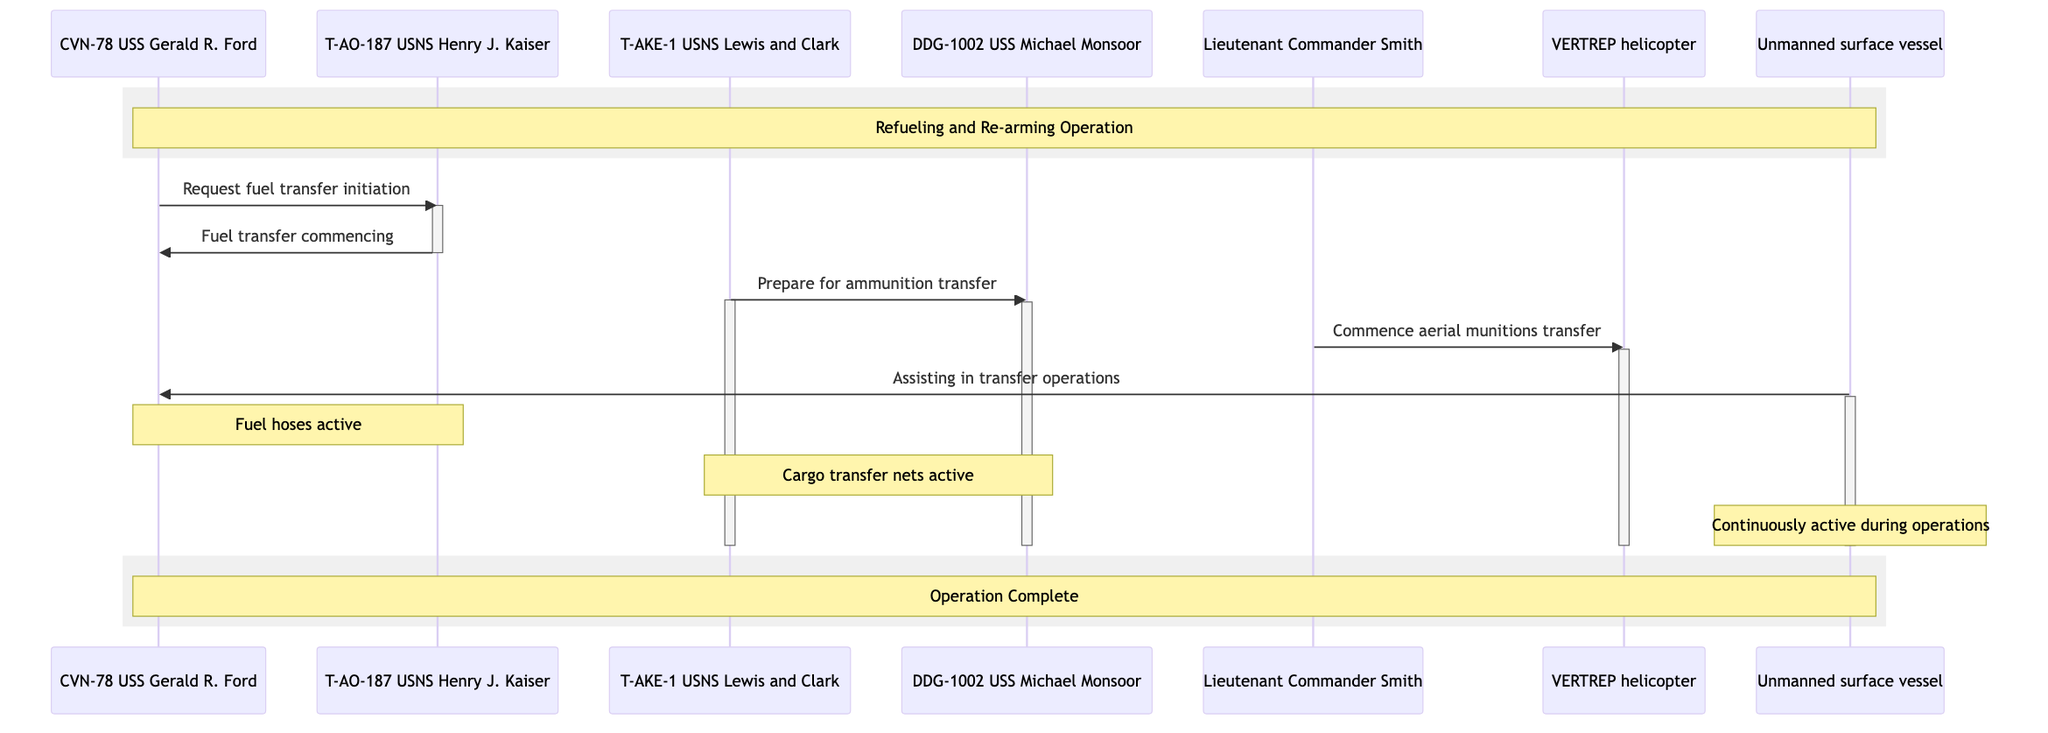What is the first message sent in the diagram? The first message sent is from the CVN-78 USS Gerald R. Ford to the T-AO-187 USNS Henry J. Kaiser, requesting fuel transfer initiation.
Answer: Request fuel transfer initiation Who assists in transfer operations continuously? The Unmanned Surface Vessel (USV) is continuously assisting in the transfer operations as stated in the lifeline notes.
Answer: Unmanned surface vessel How many ships are involved in this sequence diagram? There are four ships involved in the sequence diagram: CVN-78 USS Gerald R. Ford, T-AO-187 USNS Henry J. Kaiser, T-AKE-1 USNS Lewis and Clark, and DDG-1002 USS Michael Monsoor.
Answer: Four What is activated during the fuel transfer? Fuel hoses are activated during the fuel transfer operation according to the notes over the appropriate actors.
Answer: Fuel hoses Which actor is responsible for commencing aerial munitions transfer? Lieutenant Commander Smith is responsible for directing the VERTREP helicopter to commence aerial munitions transfer as shown by the message flow.
Answer: Lieutenant Commander Smith What entities are activated during the ammunition transfer? The T-AKE-1 USNS Lewis and Clark and the DDG-1002 USS Michael Monsoor are both activated during the ammunition transfer process as indicated by the message connections.
Answer: T-AKE-1 USNS Lewis and Clark, DDG-1002 USS Michael Monsoor What is indicated by the notes regarding the Cargo transfer nets? The notes specify that the Cargo transfer nets are active during ammunition and supplies transfer, indicating their importance for that operation.
Answer: Active during ammunition and supplies transfer What does the CVN-78 USS Gerald R. Ford receive from the T-AO-187 USNS Henry J. Kaiser? The CVN-78 USS Gerald R. Ford receives fuel from the T-AO-187 USNS Henry J. Kaiser as indicated by the flow of the messages in the diagram.
Answer: Fuel What operation is completed at the end of the diagram? The operation completed at the end of the diagram is the refueling and re-arming operation, as noted in the final rectangle in the diagram.
Answer: Operation Complete 